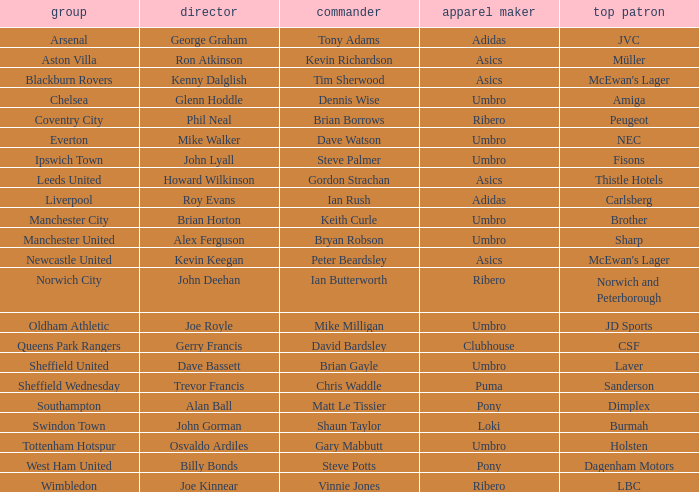Which captain has billy bonds as the manager? Steve Potts. 